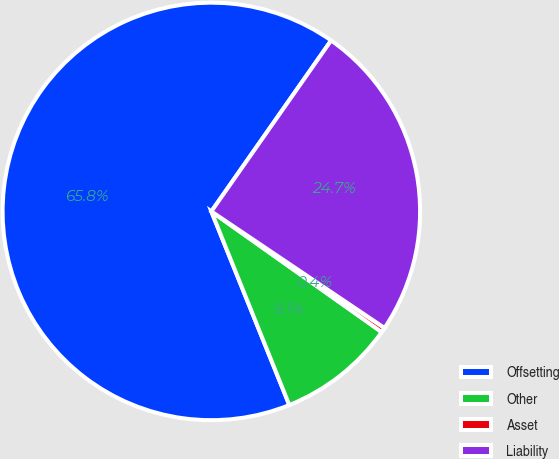Convert chart to OTSL. <chart><loc_0><loc_0><loc_500><loc_500><pie_chart><fcel>Offsetting<fcel>Other<fcel>Asset<fcel>Liability<nl><fcel>65.82%<fcel>9.1%<fcel>0.38%<fcel>24.7%<nl></chart> 